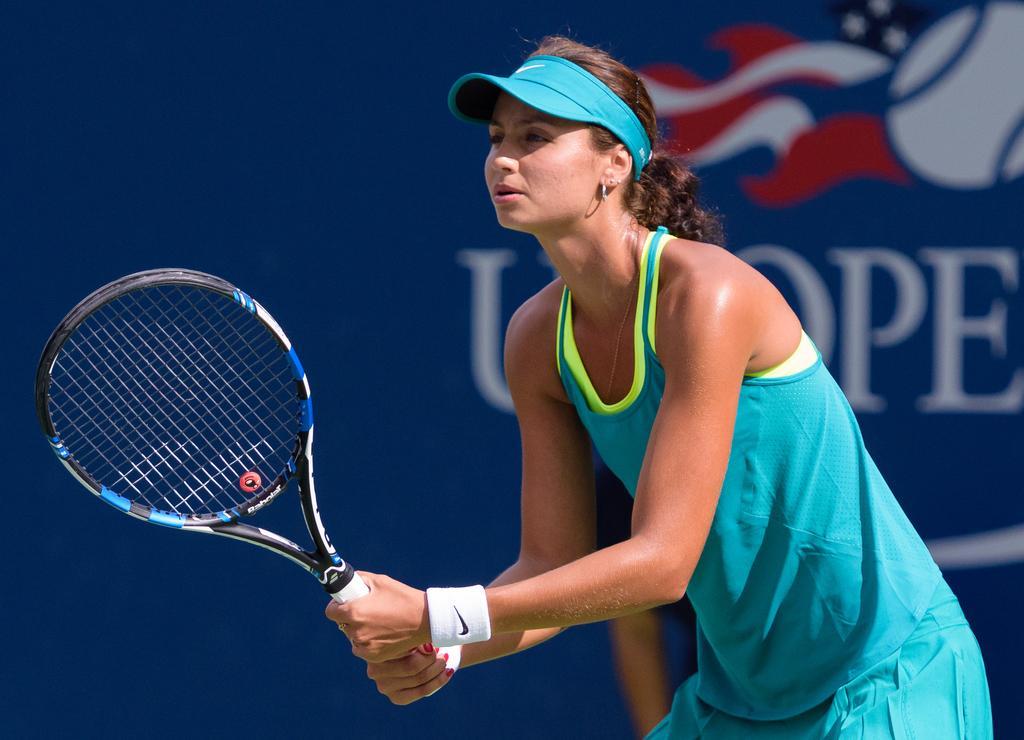Can you describe this image briefly? In this image we can see the female player holding the tennis bat. In the background we can see the blue color banner with the text. 